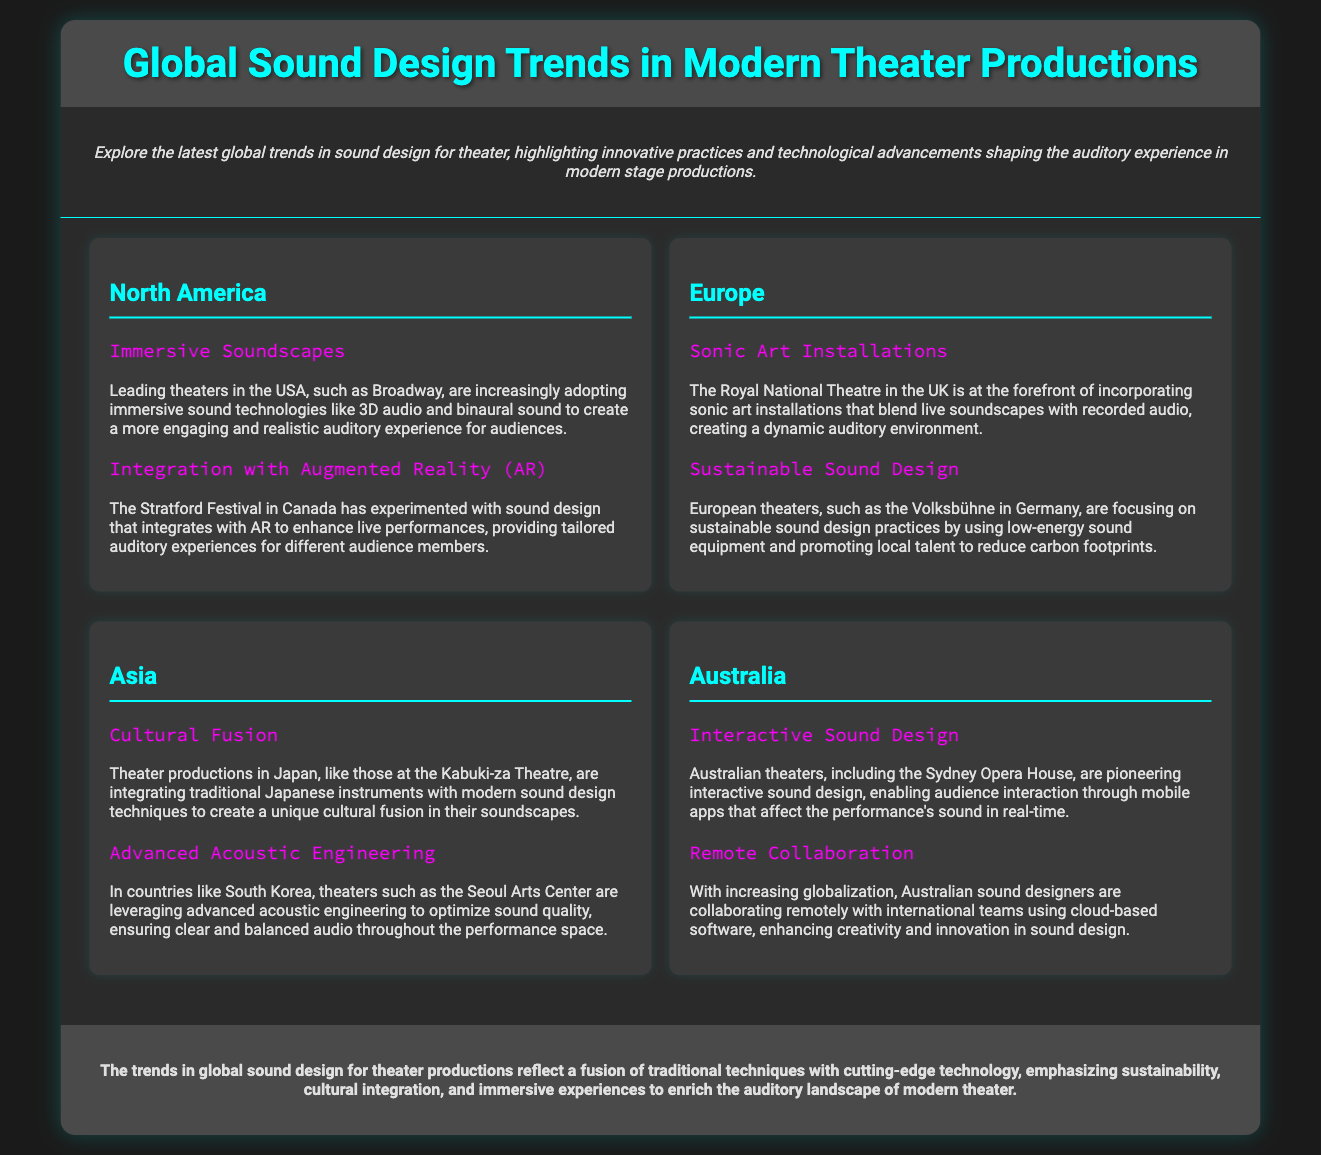What is the title of the document? The title is found in the header of the document, which is "Global Sound Design Trends in Modern Theater Productions."
Answer: Global Sound Design Trends in Modern Theater Productions Which region is known for "Immersive Soundscapes"? This information is located in the North America region, detailing the trend in sound design.
Answer: North America What technology is integrated with sound design in Canada? The document mentions that the Stratford Festival in Canada integrates sound design with augmented reality.
Answer: Augmented Reality (AR) Which European theater focuses on sustainability? It states that the Volksbühne in Germany is focusing on sustainable sound design practices.
Answer: Volksbühne What unique aspect is highlighted in Asian sound design? The document notes that productions in Japan are integrating traditional instruments for cultural fusion in their soundscapes.
Answer: Cultural Fusion How are Australian theaters enhancing audience interaction? The document indicates that Australian theaters are pioneering interactive sound design through mobile apps.
Answer: Interactive sound design Which performing arts venue is located in Australia? The document lists the Sydney Opera House as a prominent venue in Australia.
Answer: Sydney Opera House What is a notable trend in sound design within North America? The document states that leading theaters are adopting immersive sound technologies.
Answer: Immersive Soundscapes 